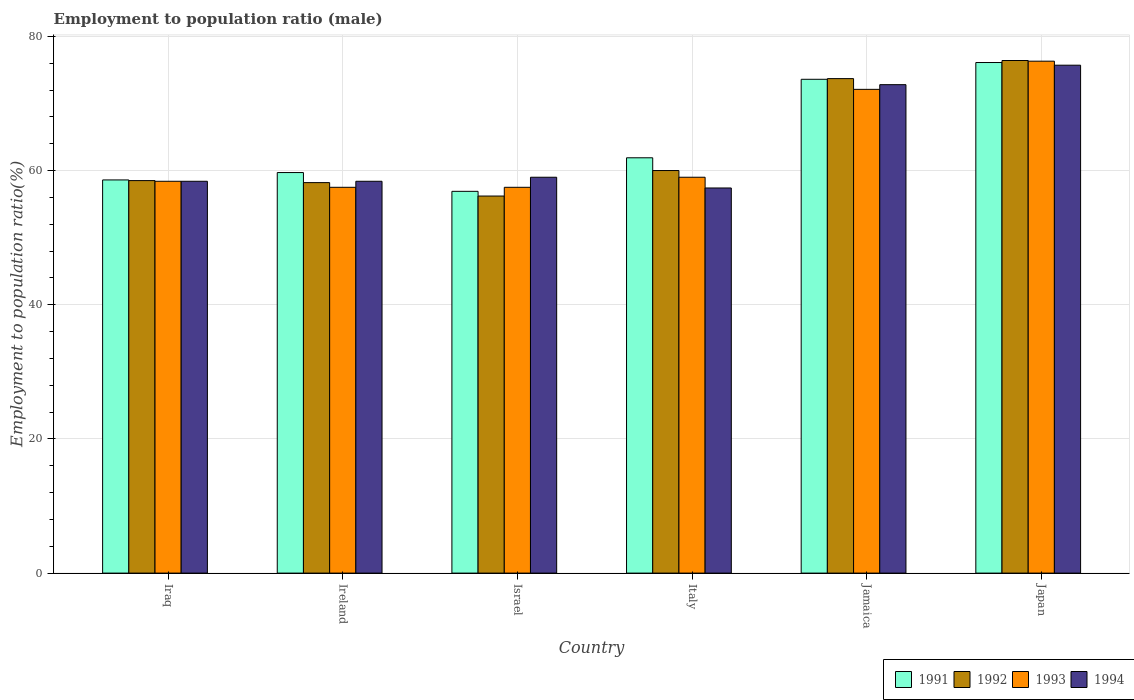How many groups of bars are there?
Ensure brevity in your answer.  6. Are the number of bars on each tick of the X-axis equal?
Your answer should be compact. Yes. What is the employment to population ratio in 1994 in Iraq?
Ensure brevity in your answer.  58.4. Across all countries, what is the maximum employment to population ratio in 1991?
Give a very brief answer. 76.1. Across all countries, what is the minimum employment to population ratio in 1993?
Keep it short and to the point. 57.5. In which country was the employment to population ratio in 1992 maximum?
Give a very brief answer. Japan. What is the total employment to population ratio in 1991 in the graph?
Your answer should be very brief. 386.8. What is the difference between the employment to population ratio in 1992 in Ireland and that in Japan?
Provide a short and direct response. -18.2. What is the difference between the employment to population ratio in 1994 in Iraq and the employment to population ratio in 1993 in Ireland?
Your response must be concise. 0.9. What is the average employment to population ratio in 1993 per country?
Your answer should be compact. 63.47. What is the difference between the employment to population ratio of/in 1994 and employment to population ratio of/in 1992 in Iraq?
Offer a very short reply. -0.1. In how many countries, is the employment to population ratio in 1992 greater than 56 %?
Your response must be concise. 6. What is the ratio of the employment to population ratio in 1992 in Iraq to that in Ireland?
Offer a terse response. 1.01. Is the employment to population ratio in 1992 in Iraq less than that in Italy?
Offer a terse response. Yes. What is the difference between the highest and the second highest employment to population ratio in 1991?
Offer a terse response. -2.5. What is the difference between the highest and the lowest employment to population ratio in 1992?
Ensure brevity in your answer.  20.2. In how many countries, is the employment to population ratio in 1993 greater than the average employment to population ratio in 1993 taken over all countries?
Provide a short and direct response. 2. Is it the case that in every country, the sum of the employment to population ratio in 1994 and employment to population ratio in 1993 is greater than the sum of employment to population ratio in 1991 and employment to population ratio in 1992?
Your answer should be compact. No. What does the 4th bar from the left in Jamaica represents?
Offer a terse response. 1994. How many bars are there?
Your answer should be very brief. 24. How many countries are there in the graph?
Provide a short and direct response. 6. Does the graph contain any zero values?
Offer a very short reply. No. Does the graph contain grids?
Your answer should be very brief. Yes. Where does the legend appear in the graph?
Your response must be concise. Bottom right. How are the legend labels stacked?
Offer a very short reply. Horizontal. What is the title of the graph?
Offer a terse response. Employment to population ratio (male). What is the Employment to population ratio(%) in 1991 in Iraq?
Offer a terse response. 58.6. What is the Employment to population ratio(%) of 1992 in Iraq?
Make the answer very short. 58.5. What is the Employment to population ratio(%) in 1993 in Iraq?
Provide a succinct answer. 58.4. What is the Employment to population ratio(%) of 1994 in Iraq?
Make the answer very short. 58.4. What is the Employment to population ratio(%) of 1991 in Ireland?
Provide a succinct answer. 59.7. What is the Employment to population ratio(%) in 1992 in Ireland?
Your answer should be compact. 58.2. What is the Employment to population ratio(%) in 1993 in Ireland?
Give a very brief answer. 57.5. What is the Employment to population ratio(%) in 1994 in Ireland?
Keep it short and to the point. 58.4. What is the Employment to population ratio(%) of 1991 in Israel?
Make the answer very short. 56.9. What is the Employment to population ratio(%) of 1992 in Israel?
Offer a terse response. 56.2. What is the Employment to population ratio(%) in 1993 in Israel?
Provide a succinct answer. 57.5. What is the Employment to population ratio(%) in 1994 in Israel?
Offer a terse response. 59. What is the Employment to population ratio(%) of 1991 in Italy?
Give a very brief answer. 61.9. What is the Employment to population ratio(%) of 1992 in Italy?
Offer a terse response. 60. What is the Employment to population ratio(%) of 1994 in Italy?
Your response must be concise. 57.4. What is the Employment to population ratio(%) in 1991 in Jamaica?
Your answer should be very brief. 73.6. What is the Employment to population ratio(%) of 1992 in Jamaica?
Keep it short and to the point. 73.7. What is the Employment to population ratio(%) in 1993 in Jamaica?
Provide a succinct answer. 72.1. What is the Employment to population ratio(%) in 1994 in Jamaica?
Your answer should be compact. 72.8. What is the Employment to population ratio(%) in 1991 in Japan?
Make the answer very short. 76.1. What is the Employment to population ratio(%) in 1992 in Japan?
Offer a terse response. 76.4. What is the Employment to population ratio(%) in 1993 in Japan?
Provide a succinct answer. 76.3. What is the Employment to population ratio(%) in 1994 in Japan?
Offer a very short reply. 75.7. Across all countries, what is the maximum Employment to population ratio(%) in 1991?
Make the answer very short. 76.1. Across all countries, what is the maximum Employment to population ratio(%) in 1992?
Offer a terse response. 76.4. Across all countries, what is the maximum Employment to population ratio(%) of 1993?
Offer a terse response. 76.3. Across all countries, what is the maximum Employment to population ratio(%) in 1994?
Keep it short and to the point. 75.7. Across all countries, what is the minimum Employment to population ratio(%) in 1991?
Provide a succinct answer. 56.9. Across all countries, what is the minimum Employment to population ratio(%) of 1992?
Your answer should be very brief. 56.2. Across all countries, what is the minimum Employment to population ratio(%) in 1993?
Give a very brief answer. 57.5. Across all countries, what is the minimum Employment to population ratio(%) of 1994?
Your answer should be compact. 57.4. What is the total Employment to population ratio(%) in 1991 in the graph?
Provide a succinct answer. 386.8. What is the total Employment to population ratio(%) of 1992 in the graph?
Your answer should be very brief. 383. What is the total Employment to population ratio(%) of 1993 in the graph?
Your answer should be compact. 380.8. What is the total Employment to population ratio(%) of 1994 in the graph?
Keep it short and to the point. 381.7. What is the difference between the Employment to population ratio(%) of 1991 in Iraq and that in Ireland?
Keep it short and to the point. -1.1. What is the difference between the Employment to population ratio(%) in 1992 in Iraq and that in Ireland?
Make the answer very short. 0.3. What is the difference between the Employment to population ratio(%) of 1993 in Iraq and that in Ireland?
Offer a terse response. 0.9. What is the difference between the Employment to population ratio(%) of 1994 in Iraq and that in Ireland?
Provide a succinct answer. 0. What is the difference between the Employment to population ratio(%) of 1991 in Iraq and that in Israel?
Your answer should be very brief. 1.7. What is the difference between the Employment to population ratio(%) in 1992 in Iraq and that in Jamaica?
Your answer should be very brief. -15.2. What is the difference between the Employment to population ratio(%) of 1993 in Iraq and that in Jamaica?
Ensure brevity in your answer.  -13.7. What is the difference between the Employment to population ratio(%) in 1994 in Iraq and that in Jamaica?
Give a very brief answer. -14.4. What is the difference between the Employment to population ratio(%) of 1991 in Iraq and that in Japan?
Give a very brief answer. -17.5. What is the difference between the Employment to population ratio(%) of 1992 in Iraq and that in Japan?
Provide a succinct answer. -17.9. What is the difference between the Employment to population ratio(%) of 1993 in Iraq and that in Japan?
Provide a short and direct response. -17.9. What is the difference between the Employment to population ratio(%) in 1994 in Iraq and that in Japan?
Your answer should be very brief. -17.3. What is the difference between the Employment to population ratio(%) in 1991 in Ireland and that in Israel?
Your answer should be compact. 2.8. What is the difference between the Employment to population ratio(%) in 1992 in Ireland and that in Italy?
Offer a terse response. -1.8. What is the difference between the Employment to population ratio(%) of 1993 in Ireland and that in Italy?
Offer a terse response. -1.5. What is the difference between the Employment to population ratio(%) in 1991 in Ireland and that in Jamaica?
Keep it short and to the point. -13.9. What is the difference between the Employment to population ratio(%) of 1992 in Ireland and that in Jamaica?
Offer a very short reply. -15.5. What is the difference between the Employment to population ratio(%) of 1993 in Ireland and that in Jamaica?
Give a very brief answer. -14.6. What is the difference between the Employment to population ratio(%) of 1994 in Ireland and that in Jamaica?
Your response must be concise. -14.4. What is the difference between the Employment to population ratio(%) of 1991 in Ireland and that in Japan?
Offer a very short reply. -16.4. What is the difference between the Employment to population ratio(%) of 1992 in Ireland and that in Japan?
Offer a terse response. -18.2. What is the difference between the Employment to population ratio(%) in 1993 in Ireland and that in Japan?
Your response must be concise. -18.8. What is the difference between the Employment to population ratio(%) in 1994 in Ireland and that in Japan?
Provide a succinct answer. -17.3. What is the difference between the Employment to population ratio(%) of 1991 in Israel and that in Italy?
Provide a succinct answer. -5. What is the difference between the Employment to population ratio(%) in 1994 in Israel and that in Italy?
Make the answer very short. 1.6. What is the difference between the Employment to population ratio(%) in 1991 in Israel and that in Jamaica?
Ensure brevity in your answer.  -16.7. What is the difference between the Employment to population ratio(%) of 1992 in Israel and that in Jamaica?
Offer a very short reply. -17.5. What is the difference between the Employment to population ratio(%) in 1993 in Israel and that in Jamaica?
Keep it short and to the point. -14.6. What is the difference between the Employment to population ratio(%) in 1994 in Israel and that in Jamaica?
Keep it short and to the point. -13.8. What is the difference between the Employment to population ratio(%) in 1991 in Israel and that in Japan?
Your response must be concise. -19.2. What is the difference between the Employment to population ratio(%) of 1992 in Israel and that in Japan?
Your answer should be very brief. -20.2. What is the difference between the Employment to population ratio(%) of 1993 in Israel and that in Japan?
Give a very brief answer. -18.8. What is the difference between the Employment to population ratio(%) of 1994 in Israel and that in Japan?
Offer a terse response. -16.7. What is the difference between the Employment to population ratio(%) in 1991 in Italy and that in Jamaica?
Make the answer very short. -11.7. What is the difference between the Employment to population ratio(%) of 1992 in Italy and that in Jamaica?
Your answer should be very brief. -13.7. What is the difference between the Employment to population ratio(%) in 1994 in Italy and that in Jamaica?
Provide a succinct answer. -15.4. What is the difference between the Employment to population ratio(%) in 1992 in Italy and that in Japan?
Ensure brevity in your answer.  -16.4. What is the difference between the Employment to population ratio(%) in 1993 in Italy and that in Japan?
Make the answer very short. -17.3. What is the difference between the Employment to population ratio(%) of 1994 in Italy and that in Japan?
Your answer should be very brief. -18.3. What is the difference between the Employment to population ratio(%) in 1991 in Jamaica and that in Japan?
Your response must be concise. -2.5. What is the difference between the Employment to population ratio(%) in 1993 in Jamaica and that in Japan?
Your answer should be compact. -4.2. What is the difference between the Employment to population ratio(%) in 1994 in Jamaica and that in Japan?
Give a very brief answer. -2.9. What is the difference between the Employment to population ratio(%) in 1991 in Iraq and the Employment to population ratio(%) in 1993 in Ireland?
Provide a short and direct response. 1.1. What is the difference between the Employment to population ratio(%) of 1992 in Iraq and the Employment to population ratio(%) of 1993 in Ireland?
Your response must be concise. 1. What is the difference between the Employment to population ratio(%) of 1992 in Iraq and the Employment to population ratio(%) of 1993 in Israel?
Provide a short and direct response. 1. What is the difference between the Employment to population ratio(%) in 1992 in Iraq and the Employment to population ratio(%) in 1994 in Italy?
Your answer should be very brief. 1.1. What is the difference between the Employment to population ratio(%) in 1993 in Iraq and the Employment to population ratio(%) in 1994 in Italy?
Offer a terse response. 1. What is the difference between the Employment to population ratio(%) in 1991 in Iraq and the Employment to population ratio(%) in 1992 in Jamaica?
Your answer should be compact. -15.1. What is the difference between the Employment to population ratio(%) of 1991 in Iraq and the Employment to population ratio(%) of 1994 in Jamaica?
Your answer should be compact. -14.2. What is the difference between the Employment to population ratio(%) in 1992 in Iraq and the Employment to population ratio(%) in 1993 in Jamaica?
Your answer should be very brief. -13.6. What is the difference between the Employment to population ratio(%) in 1992 in Iraq and the Employment to population ratio(%) in 1994 in Jamaica?
Provide a short and direct response. -14.3. What is the difference between the Employment to population ratio(%) in 1993 in Iraq and the Employment to population ratio(%) in 1994 in Jamaica?
Your answer should be compact. -14.4. What is the difference between the Employment to population ratio(%) of 1991 in Iraq and the Employment to population ratio(%) of 1992 in Japan?
Offer a very short reply. -17.8. What is the difference between the Employment to population ratio(%) of 1991 in Iraq and the Employment to population ratio(%) of 1993 in Japan?
Your response must be concise. -17.7. What is the difference between the Employment to population ratio(%) of 1991 in Iraq and the Employment to population ratio(%) of 1994 in Japan?
Provide a short and direct response. -17.1. What is the difference between the Employment to population ratio(%) of 1992 in Iraq and the Employment to population ratio(%) of 1993 in Japan?
Provide a short and direct response. -17.8. What is the difference between the Employment to population ratio(%) in 1992 in Iraq and the Employment to population ratio(%) in 1994 in Japan?
Your answer should be compact. -17.2. What is the difference between the Employment to population ratio(%) in 1993 in Iraq and the Employment to population ratio(%) in 1994 in Japan?
Make the answer very short. -17.3. What is the difference between the Employment to population ratio(%) in 1991 in Ireland and the Employment to population ratio(%) in 1992 in Israel?
Give a very brief answer. 3.5. What is the difference between the Employment to population ratio(%) in 1992 in Ireland and the Employment to population ratio(%) in 1994 in Israel?
Ensure brevity in your answer.  -0.8. What is the difference between the Employment to population ratio(%) in 1991 in Ireland and the Employment to population ratio(%) in 1993 in Italy?
Give a very brief answer. 0.7. What is the difference between the Employment to population ratio(%) of 1992 in Ireland and the Employment to population ratio(%) of 1994 in Italy?
Your answer should be very brief. 0.8. What is the difference between the Employment to population ratio(%) of 1991 in Ireland and the Employment to population ratio(%) of 1992 in Jamaica?
Your response must be concise. -14. What is the difference between the Employment to population ratio(%) of 1991 in Ireland and the Employment to population ratio(%) of 1993 in Jamaica?
Your response must be concise. -12.4. What is the difference between the Employment to population ratio(%) in 1992 in Ireland and the Employment to population ratio(%) in 1993 in Jamaica?
Ensure brevity in your answer.  -13.9. What is the difference between the Employment to population ratio(%) of 1992 in Ireland and the Employment to population ratio(%) of 1994 in Jamaica?
Your answer should be very brief. -14.6. What is the difference between the Employment to population ratio(%) of 1993 in Ireland and the Employment to population ratio(%) of 1994 in Jamaica?
Your response must be concise. -15.3. What is the difference between the Employment to population ratio(%) in 1991 in Ireland and the Employment to population ratio(%) in 1992 in Japan?
Give a very brief answer. -16.7. What is the difference between the Employment to population ratio(%) in 1991 in Ireland and the Employment to population ratio(%) in 1993 in Japan?
Your answer should be compact. -16.6. What is the difference between the Employment to population ratio(%) of 1992 in Ireland and the Employment to population ratio(%) of 1993 in Japan?
Provide a succinct answer. -18.1. What is the difference between the Employment to population ratio(%) of 1992 in Ireland and the Employment to population ratio(%) of 1994 in Japan?
Your response must be concise. -17.5. What is the difference between the Employment to population ratio(%) in 1993 in Ireland and the Employment to population ratio(%) in 1994 in Japan?
Offer a very short reply. -18.2. What is the difference between the Employment to population ratio(%) in 1991 in Israel and the Employment to population ratio(%) in 1993 in Italy?
Offer a terse response. -2.1. What is the difference between the Employment to population ratio(%) in 1991 in Israel and the Employment to population ratio(%) in 1994 in Italy?
Your answer should be very brief. -0.5. What is the difference between the Employment to population ratio(%) of 1992 in Israel and the Employment to population ratio(%) of 1993 in Italy?
Provide a short and direct response. -2.8. What is the difference between the Employment to population ratio(%) of 1993 in Israel and the Employment to population ratio(%) of 1994 in Italy?
Offer a very short reply. 0.1. What is the difference between the Employment to population ratio(%) of 1991 in Israel and the Employment to population ratio(%) of 1992 in Jamaica?
Make the answer very short. -16.8. What is the difference between the Employment to population ratio(%) of 1991 in Israel and the Employment to population ratio(%) of 1993 in Jamaica?
Provide a succinct answer. -15.2. What is the difference between the Employment to population ratio(%) in 1991 in Israel and the Employment to population ratio(%) in 1994 in Jamaica?
Your answer should be compact. -15.9. What is the difference between the Employment to population ratio(%) of 1992 in Israel and the Employment to population ratio(%) of 1993 in Jamaica?
Provide a short and direct response. -15.9. What is the difference between the Employment to population ratio(%) of 1992 in Israel and the Employment to population ratio(%) of 1994 in Jamaica?
Your answer should be compact. -16.6. What is the difference between the Employment to population ratio(%) in 1993 in Israel and the Employment to population ratio(%) in 1994 in Jamaica?
Provide a succinct answer. -15.3. What is the difference between the Employment to population ratio(%) of 1991 in Israel and the Employment to population ratio(%) of 1992 in Japan?
Offer a very short reply. -19.5. What is the difference between the Employment to population ratio(%) of 1991 in Israel and the Employment to population ratio(%) of 1993 in Japan?
Offer a very short reply. -19.4. What is the difference between the Employment to population ratio(%) of 1991 in Israel and the Employment to population ratio(%) of 1994 in Japan?
Your answer should be very brief. -18.8. What is the difference between the Employment to population ratio(%) of 1992 in Israel and the Employment to population ratio(%) of 1993 in Japan?
Your answer should be compact. -20.1. What is the difference between the Employment to population ratio(%) of 1992 in Israel and the Employment to population ratio(%) of 1994 in Japan?
Make the answer very short. -19.5. What is the difference between the Employment to population ratio(%) of 1993 in Israel and the Employment to population ratio(%) of 1994 in Japan?
Give a very brief answer. -18.2. What is the difference between the Employment to population ratio(%) of 1991 in Italy and the Employment to population ratio(%) of 1992 in Jamaica?
Ensure brevity in your answer.  -11.8. What is the difference between the Employment to population ratio(%) in 1992 in Italy and the Employment to population ratio(%) in 1993 in Jamaica?
Your response must be concise. -12.1. What is the difference between the Employment to population ratio(%) in 1992 in Italy and the Employment to population ratio(%) in 1994 in Jamaica?
Provide a succinct answer. -12.8. What is the difference between the Employment to population ratio(%) in 1991 in Italy and the Employment to population ratio(%) in 1993 in Japan?
Ensure brevity in your answer.  -14.4. What is the difference between the Employment to population ratio(%) of 1991 in Italy and the Employment to population ratio(%) of 1994 in Japan?
Your response must be concise. -13.8. What is the difference between the Employment to population ratio(%) in 1992 in Italy and the Employment to population ratio(%) in 1993 in Japan?
Your answer should be compact. -16.3. What is the difference between the Employment to population ratio(%) of 1992 in Italy and the Employment to population ratio(%) of 1994 in Japan?
Make the answer very short. -15.7. What is the difference between the Employment to population ratio(%) of 1993 in Italy and the Employment to population ratio(%) of 1994 in Japan?
Provide a short and direct response. -16.7. What is the difference between the Employment to population ratio(%) in 1991 in Jamaica and the Employment to population ratio(%) in 1994 in Japan?
Your response must be concise. -2.1. What is the difference between the Employment to population ratio(%) in 1993 in Jamaica and the Employment to population ratio(%) in 1994 in Japan?
Your answer should be very brief. -3.6. What is the average Employment to population ratio(%) of 1991 per country?
Provide a succinct answer. 64.47. What is the average Employment to population ratio(%) in 1992 per country?
Provide a succinct answer. 63.83. What is the average Employment to population ratio(%) in 1993 per country?
Provide a succinct answer. 63.47. What is the average Employment to population ratio(%) of 1994 per country?
Your answer should be compact. 63.62. What is the difference between the Employment to population ratio(%) in 1991 and Employment to population ratio(%) in 1993 in Iraq?
Offer a very short reply. 0.2. What is the difference between the Employment to population ratio(%) of 1993 and Employment to population ratio(%) of 1994 in Iraq?
Your answer should be very brief. 0. What is the difference between the Employment to population ratio(%) in 1991 and Employment to population ratio(%) in 1993 in Ireland?
Ensure brevity in your answer.  2.2. What is the difference between the Employment to population ratio(%) in 1991 and Employment to population ratio(%) in 1994 in Ireland?
Give a very brief answer. 1.3. What is the difference between the Employment to population ratio(%) of 1992 and Employment to population ratio(%) of 1993 in Ireland?
Provide a succinct answer. 0.7. What is the difference between the Employment to population ratio(%) of 1993 and Employment to population ratio(%) of 1994 in Israel?
Make the answer very short. -1.5. What is the difference between the Employment to population ratio(%) of 1991 and Employment to population ratio(%) of 1992 in Italy?
Your answer should be very brief. 1.9. What is the difference between the Employment to population ratio(%) in 1992 and Employment to population ratio(%) in 1994 in Italy?
Give a very brief answer. 2.6. What is the difference between the Employment to population ratio(%) of 1993 and Employment to population ratio(%) of 1994 in Italy?
Provide a short and direct response. 1.6. What is the difference between the Employment to population ratio(%) of 1991 and Employment to population ratio(%) of 1992 in Jamaica?
Provide a succinct answer. -0.1. What is the difference between the Employment to population ratio(%) of 1991 and Employment to population ratio(%) of 1993 in Jamaica?
Keep it short and to the point. 1.5. What is the difference between the Employment to population ratio(%) in 1992 and Employment to population ratio(%) in 1994 in Jamaica?
Offer a very short reply. 0.9. What is the difference between the Employment to population ratio(%) in 1993 and Employment to population ratio(%) in 1994 in Jamaica?
Offer a very short reply. -0.7. What is the difference between the Employment to population ratio(%) in 1991 and Employment to population ratio(%) in 1994 in Japan?
Provide a short and direct response. 0.4. What is the difference between the Employment to population ratio(%) in 1992 and Employment to population ratio(%) in 1994 in Japan?
Your response must be concise. 0.7. What is the difference between the Employment to population ratio(%) of 1993 and Employment to population ratio(%) of 1994 in Japan?
Your response must be concise. 0.6. What is the ratio of the Employment to population ratio(%) in 1991 in Iraq to that in Ireland?
Your response must be concise. 0.98. What is the ratio of the Employment to population ratio(%) of 1993 in Iraq to that in Ireland?
Your answer should be compact. 1.02. What is the ratio of the Employment to population ratio(%) of 1991 in Iraq to that in Israel?
Your answer should be very brief. 1.03. What is the ratio of the Employment to population ratio(%) in 1992 in Iraq to that in Israel?
Offer a very short reply. 1.04. What is the ratio of the Employment to population ratio(%) in 1993 in Iraq to that in Israel?
Your answer should be compact. 1.02. What is the ratio of the Employment to population ratio(%) in 1991 in Iraq to that in Italy?
Provide a short and direct response. 0.95. What is the ratio of the Employment to population ratio(%) of 1992 in Iraq to that in Italy?
Make the answer very short. 0.97. What is the ratio of the Employment to population ratio(%) of 1994 in Iraq to that in Italy?
Ensure brevity in your answer.  1.02. What is the ratio of the Employment to population ratio(%) of 1991 in Iraq to that in Jamaica?
Give a very brief answer. 0.8. What is the ratio of the Employment to population ratio(%) of 1992 in Iraq to that in Jamaica?
Make the answer very short. 0.79. What is the ratio of the Employment to population ratio(%) in 1993 in Iraq to that in Jamaica?
Ensure brevity in your answer.  0.81. What is the ratio of the Employment to population ratio(%) in 1994 in Iraq to that in Jamaica?
Your answer should be compact. 0.8. What is the ratio of the Employment to population ratio(%) of 1991 in Iraq to that in Japan?
Make the answer very short. 0.77. What is the ratio of the Employment to population ratio(%) of 1992 in Iraq to that in Japan?
Provide a succinct answer. 0.77. What is the ratio of the Employment to population ratio(%) of 1993 in Iraq to that in Japan?
Ensure brevity in your answer.  0.77. What is the ratio of the Employment to population ratio(%) of 1994 in Iraq to that in Japan?
Offer a very short reply. 0.77. What is the ratio of the Employment to population ratio(%) of 1991 in Ireland to that in Israel?
Offer a very short reply. 1.05. What is the ratio of the Employment to population ratio(%) in 1992 in Ireland to that in Israel?
Give a very brief answer. 1.04. What is the ratio of the Employment to population ratio(%) in 1994 in Ireland to that in Israel?
Your response must be concise. 0.99. What is the ratio of the Employment to population ratio(%) of 1991 in Ireland to that in Italy?
Provide a short and direct response. 0.96. What is the ratio of the Employment to population ratio(%) of 1993 in Ireland to that in Italy?
Keep it short and to the point. 0.97. What is the ratio of the Employment to population ratio(%) of 1994 in Ireland to that in Italy?
Provide a short and direct response. 1.02. What is the ratio of the Employment to population ratio(%) in 1991 in Ireland to that in Jamaica?
Your response must be concise. 0.81. What is the ratio of the Employment to population ratio(%) of 1992 in Ireland to that in Jamaica?
Ensure brevity in your answer.  0.79. What is the ratio of the Employment to population ratio(%) of 1993 in Ireland to that in Jamaica?
Give a very brief answer. 0.8. What is the ratio of the Employment to population ratio(%) of 1994 in Ireland to that in Jamaica?
Provide a short and direct response. 0.8. What is the ratio of the Employment to population ratio(%) of 1991 in Ireland to that in Japan?
Make the answer very short. 0.78. What is the ratio of the Employment to population ratio(%) of 1992 in Ireland to that in Japan?
Provide a short and direct response. 0.76. What is the ratio of the Employment to population ratio(%) in 1993 in Ireland to that in Japan?
Offer a terse response. 0.75. What is the ratio of the Employment to population ratio(%) of 1994 in Ireland to that in Japan?
Make the answer very short. 0.77. What is the ratio of the Employment to population ratio(%) of 1991 in Israel to that in Italy?
Ensure brevity in your answer.  0.92. What is the ratio of the Employment to population ratio(%) of 1992 in Israel to that in Italy?
Make the answer very short. 0.94. What is the ratio of the Employment to population ratio(%) of 1993 in Israel to that in Italy?
Keep it short and to the point. 0.97. What is the ratio of the Employment to population ratio(%) of 1994 in Israel to that in Italy?
Make the answer very short. 1.03. What is the ratio of the Employment to population ratio(%) in 1991 in Israel to that in Jamaica?
Make the answer very short. 0.77. What is the ratio of the Employment to population ratio(%) in 1992 in Israel to that in Jamaica?
Your answer should be very brief. 0.76. What is the ratio of the Employment to population ratio(%) of 1993 in Israel to that in Jamaica?
Your answer should be very brief. 0.8. What is the ratio of the Employment to population ratio(%) in 1994 in Israel to that in Jamaica?
Ensure brevity in your answer.  0.81. What is the ratio of the Employment to population ratio(%) in 1991 in Israel to that in Japan?
Provide a succinct answer. 0.75. What is the ratio of the Employment to population ratio(%) of 1992 in Israel to that in Japan?
Give a very brief answer. 0.74. What is the ratio of the Employment to population ratio(%) of 1993 in Israel to that in Japan?
Offer a very short reply. 0.75. What is the ratio of the Employment to population ratio(%) in 1994 in Israel to that in Japan?
Your answer should be very brief. 0.78. What is the ratio of the Employment to population ratio(%) in 1991 in Italy to that in Jamaica?
Your response must be concise. 0.84. What is the ratio of the Employment to population ratio(%) of 1992 in Italy to that in Jamaica?
Your answer should be very brief. 0.81. What is the ratio of the Employment to population ratio(%) of 1993 in Italy to that in Jamaica?
Ensure brevity in your answer.  0.82. What is the ratio of the Employment to population ratio(%) in 1994 in Italy to that in Jamaica?
Provide a short and direct response. 0.79. What is the ratio of the Employment to population ratio(%) of 1991 in Italy to that in Japan?
Offer a very short reply. 0.81. What is the ratio of the Employment to population ratio(%) of 1992 in Italy to that in Japan?
Your answer should be very brief. 0.79. What is the ratio of the Employment to population ratio(%) of 1993 in Italy to that in Japan?
Provide a short and direct response. 0.77. What is the ratio of the Employment to population ratio(%) of 1994 in Italy to that in Japan?
Your answer should be compact. 0.76. What is the ratio of the Employment to population ratio(%) of 1991 in Jamaica to that in Japan?
Offer a terse response. 0.97. What is the ratio of the Employment to population ratio(%) of 1992 in Jamaica to that in Japan?
Your answer should be compact. 0.96. What is the ratio of the Employment to population ratio(%) of 1993 in Jamaica to that in Japan?
Make the answer very short. 0.94. What is the ratio of the Employment to population ratio(%) in 1994 in Jamaica to that in Japan?
Your response must be concise. 0.96. What is the difference between the highest and the second highest Employment to population ratio(%) of 1991?
Offer a terse response. 2.5. What is the difference between the highest and the lowest Employment to population ratio(%) in 1992?
Keep it short and to the point. 20.2. What is the difference between the highest and the lowest Employment to population ratio(%) in 1994?
Offer a terse response. 18.3. 